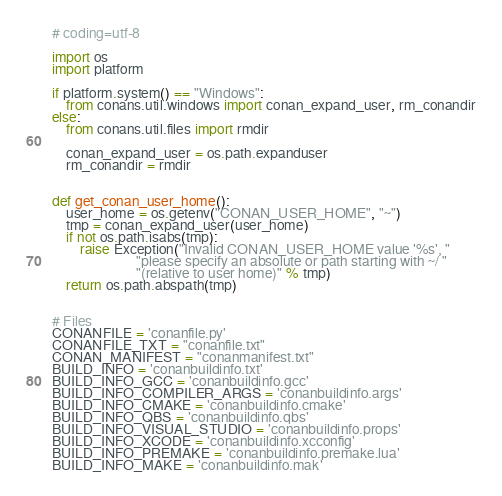<code> <loc_0><loc_0><loc_500><loc_500><_Python_># coding=utf-8

import os
import platform

if platform.system() == "Windows":
    from conans.util.windows import conan_expand_user, rm_conandir
else:
    from conans.util.files import rmdir

    conan_expand_user = os.path.expanduser
    rm_conandir = rmdir


def get_conan_user_home():
    user_home = os.getenv("CONAN_USER_HOME", "~")
    tmp = conan_expand_user(user_home)
    if not os.path.isabs(tmp):
        raise Exception("Invalid CONAN_USER_HOME value '%s', "
                        "please specify an absolute or path starting with ~/ "
                        "(relative to user home)" % tmp)
    return os.path.abspath(tmp)


# Files
CONANFILE = 'conanfile.py'
CONANFILE_TXT = "conanfile.txt"
CONAN_MANIFEST = "conanmanifest.txt"
BUILD_INFO = 'conanbuildinfo.txt'
BUILD_INFO_GCC = 'conanbuildinfo.gcc'
BUILD_INFO_COMPILER_ARGS = 'conanbuildinfo.args'
BUILD_INFO_CMAKE = 'conanbuildinfo.cmake'
BUILD_INFO_QBS = 'conanbuildinfo.qbs'
BUILD_INFO_VISUAL_STUDIO = 'conanbuildinfo.props'
BUILD_INFO_XCODE = 'conanbuildinfo.xcconfig'
BUILD_INFO_PREMAKE = 'conanbuildinfo.premake.lua'
BUILD_INFO_MAKE = 'conanbuildinfo.mak'</code> 